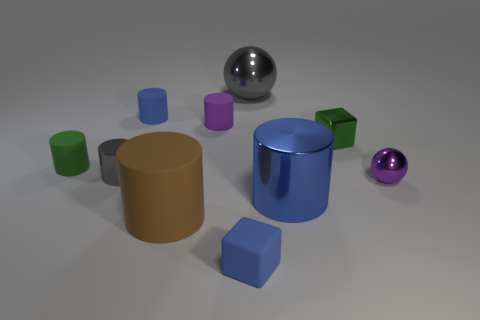Subtract 4 cylinders. How many cylinders are left? 2 Subtract all small purple cylinders. How many cylinders are left? 5 Subtract all cyan balls. How many blue cylinders are left? 2 Subtract all gray cylinders. How many cylinders are left? 5 Subtract all green cylinders. Subtract all brown blocks. How many cylinders are left? 5 Subtract all cylinders. How many objects are left? 4 Subtract all tiny red objects. Subtract all green cylinders. How many objects are left? 9 Add 5 small green objects. How many small green objects are left? 7 Add 1 green cylinders. How many green cylinders exist? 2 Subtract 1 gray spheres. How many objects are left? 9 